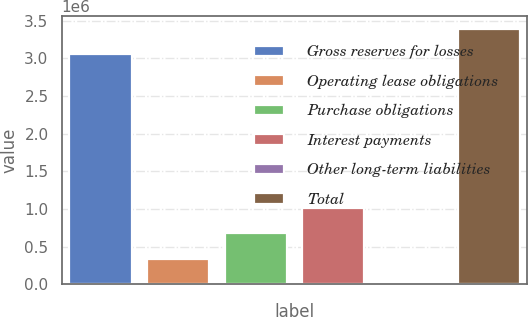Convert chart to OTSL. <chart><loc_0><loc_0><loc_500><loc_500><bar_chart><fcel>Gross reserves for losses<fcel>Operating lease obligations<fcel>Purchase obligations<fcel>Interest payments<fcel>Other long-term liabilities<fcel>Total<nl><fcel>3.05515e+06<fcel>340654<fcel>677905<fcel>1.01516e+06<fcel>3402<fcel>3.3924e+06<nl></chart> 